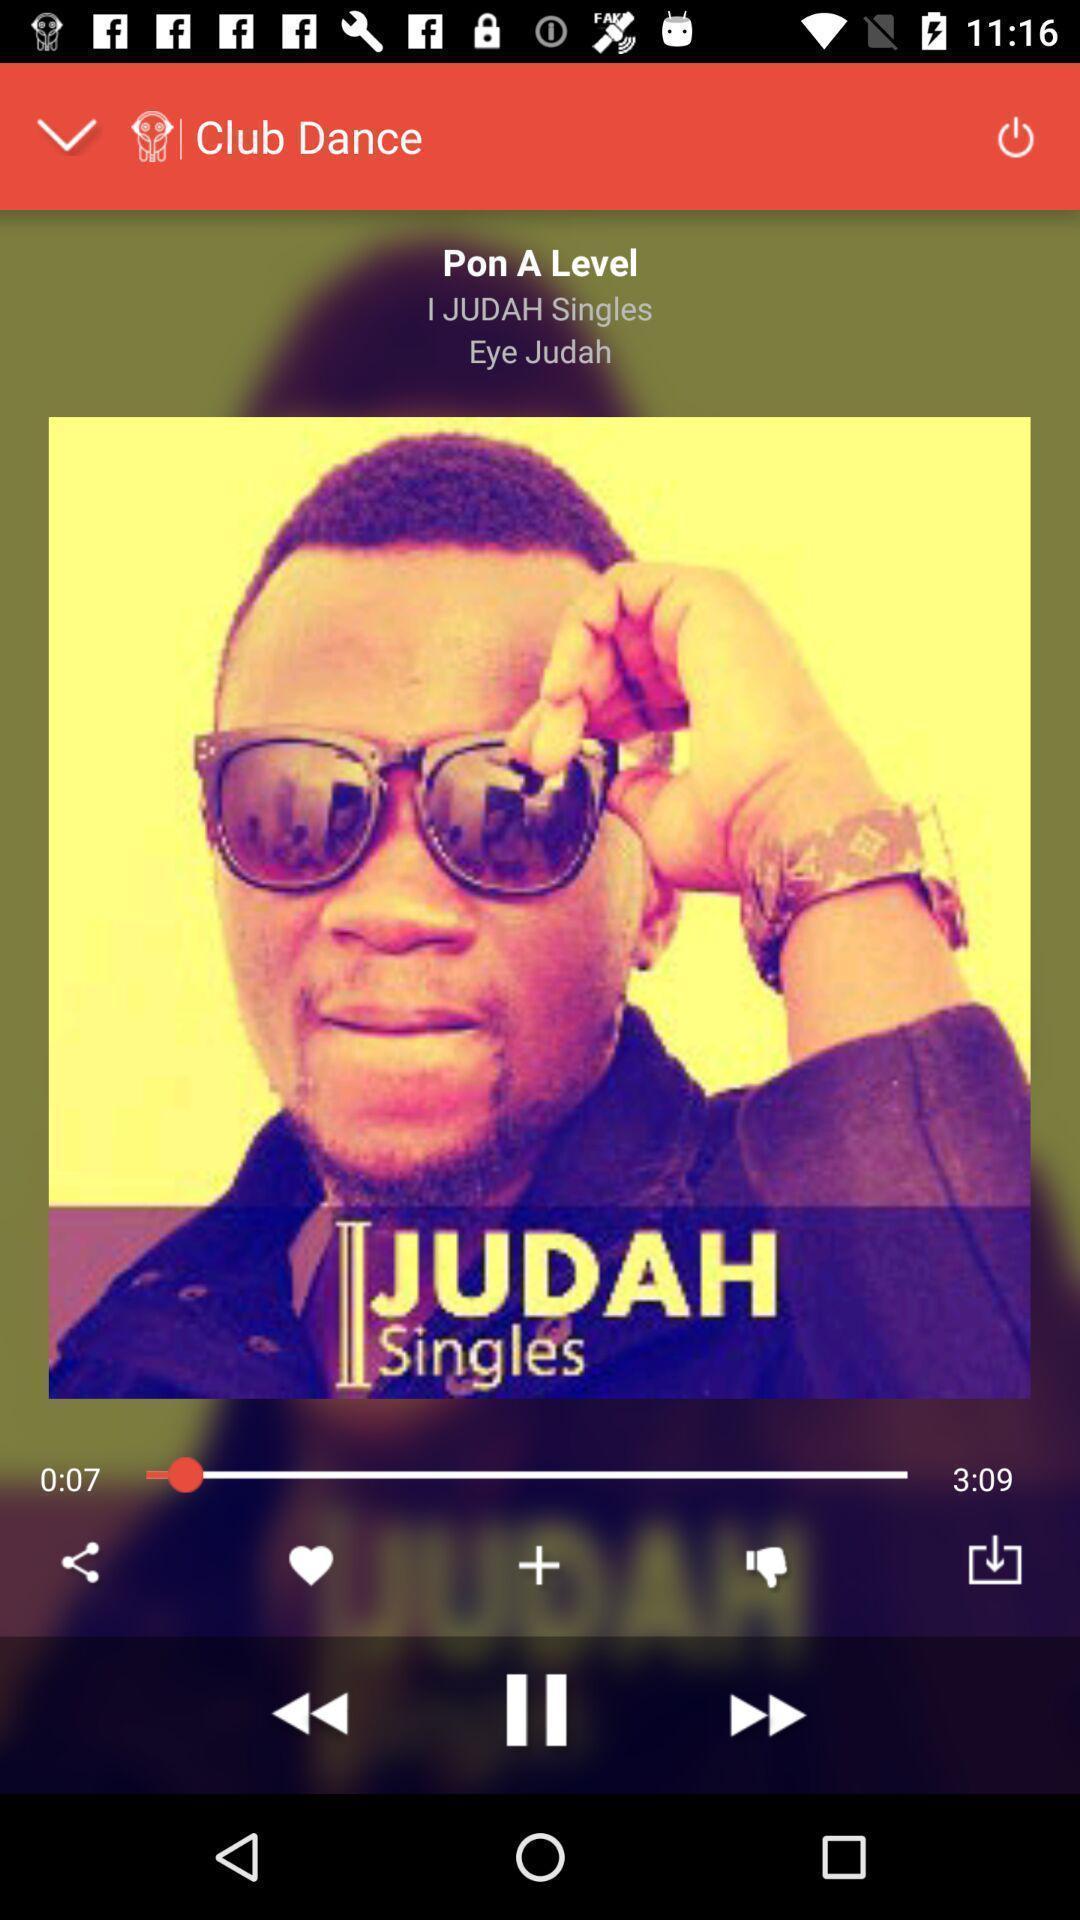Describe this image in words. Page of a music application. 